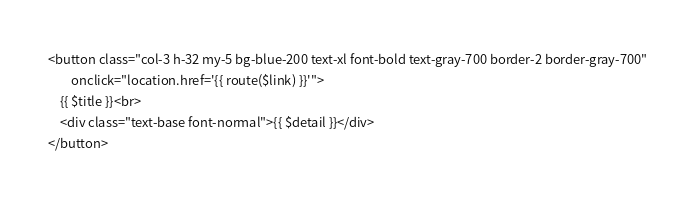Convert code to text. <code><loc_0><loc_0><loc_500><loc_500><_PHP_><button class="col-3 h-32 my-5 bg-blue-200 text-xl font-bold text-gray-700 border-2 border-gray-700"
        onclick="location.href='{{ route($link) }}'">
    {{ $title }}<br>
    <div class="text-base font-normal">{{ $detail }}</div>
</button>
</code> 